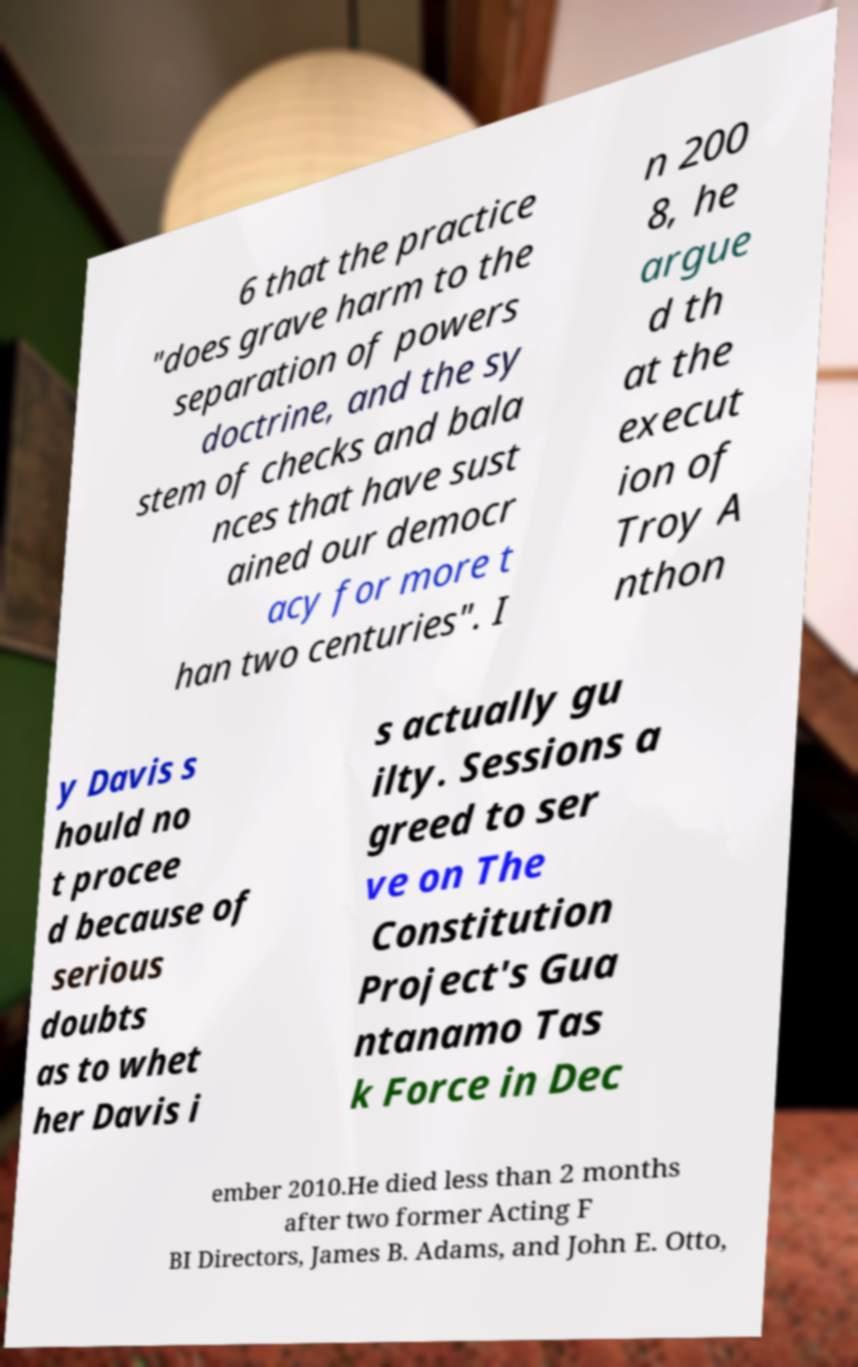Can you accurately transcribe the text from the provided image for me? 6 that the practice "does grave harm to the separation of powers doctrine, and the sy stem of checks and bala nces that have sust ained our democr acy for more t han two centuries". I n 200 8, he argue d th at the execut ion of Troy A nthon y Davis s hould no t procee d because of serious doubts as to whet her Davis i s actually gu ilty. Sessions a greed to ser ve on The Constitution Project's Gua ntanamo Tas k Force in Dec ember 2010.He died less than 2 months after two former Acting F BI Directors, James B. Adams, and John E. Otto, 